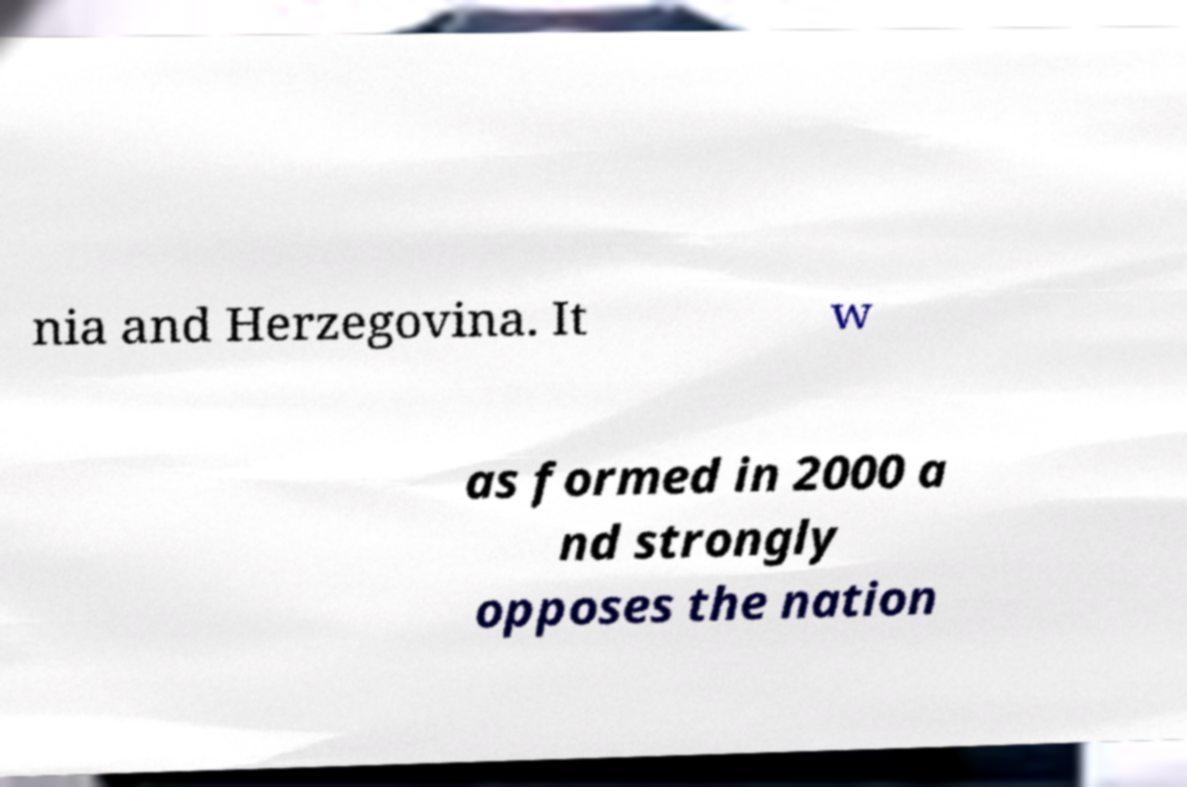Could you assist in decoding the text presented in this image and type it out clearly? nia and Herzegovina. It w as formed in 2000 a nd strongly opposes the nation 